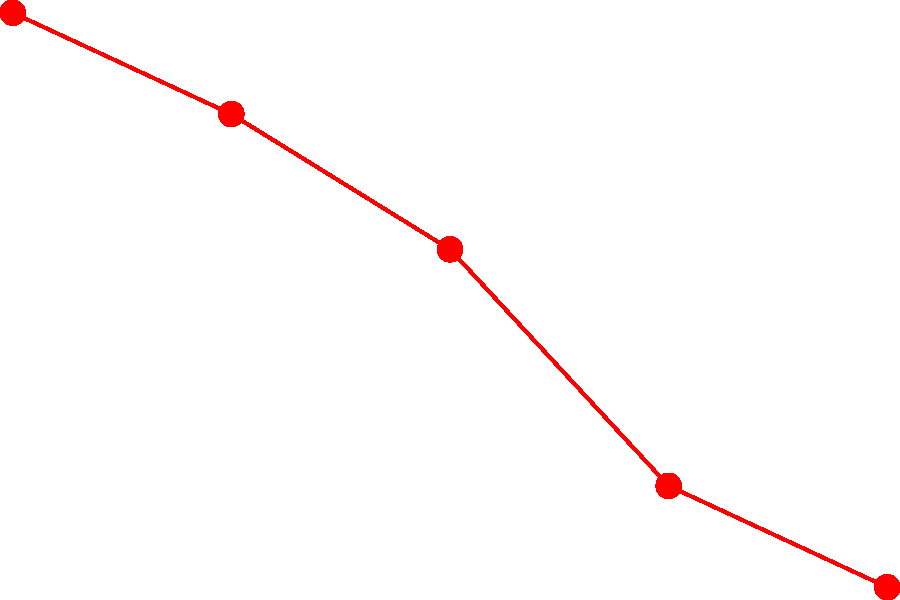Analyze the line chart depicting crime rates before and after the implementation of body cameras. Calculate the percentage decrease in crime rate from 2018 to 2022. How might this data be used to address public concerns about police accountability? To calculate the percentage decrease in crime rate from 2018 to 2022:

1. Identify the crime rates:
   2018: 65 per 1000 residents
   2022: 48 per 1000 residents

2. Calculate the decrease:
   $65 - 48 = 17$ per 1000 residents

3. Calculate the percentage decrease:
   $\text{Percentage decrease} = \frac{\text{Decrease}}{\text{Original value}} \times 100\%$
   $= \frac{17}{65} \times 100\% = 26.15\%$

4. Addressing public concerns:
   a) The data shows a consistent decrease in crime rates after implementing body cameras in 2019.
   b) This suggests improved police accountability and effectiveness.
   c) The significant 26.15% decrease can be used to demonstrate the positive impact of body cameras on public safety.
   d) It provides evidence that the police force is adapting to public concerns and implementing measures to enhance transparency.
   e) The data can be used in community outreach programs to rebuild trust between law enforcement and the public.
Answer: 26.15% decrease; data shows improved accountability and effectiveness after body camera implementation. 